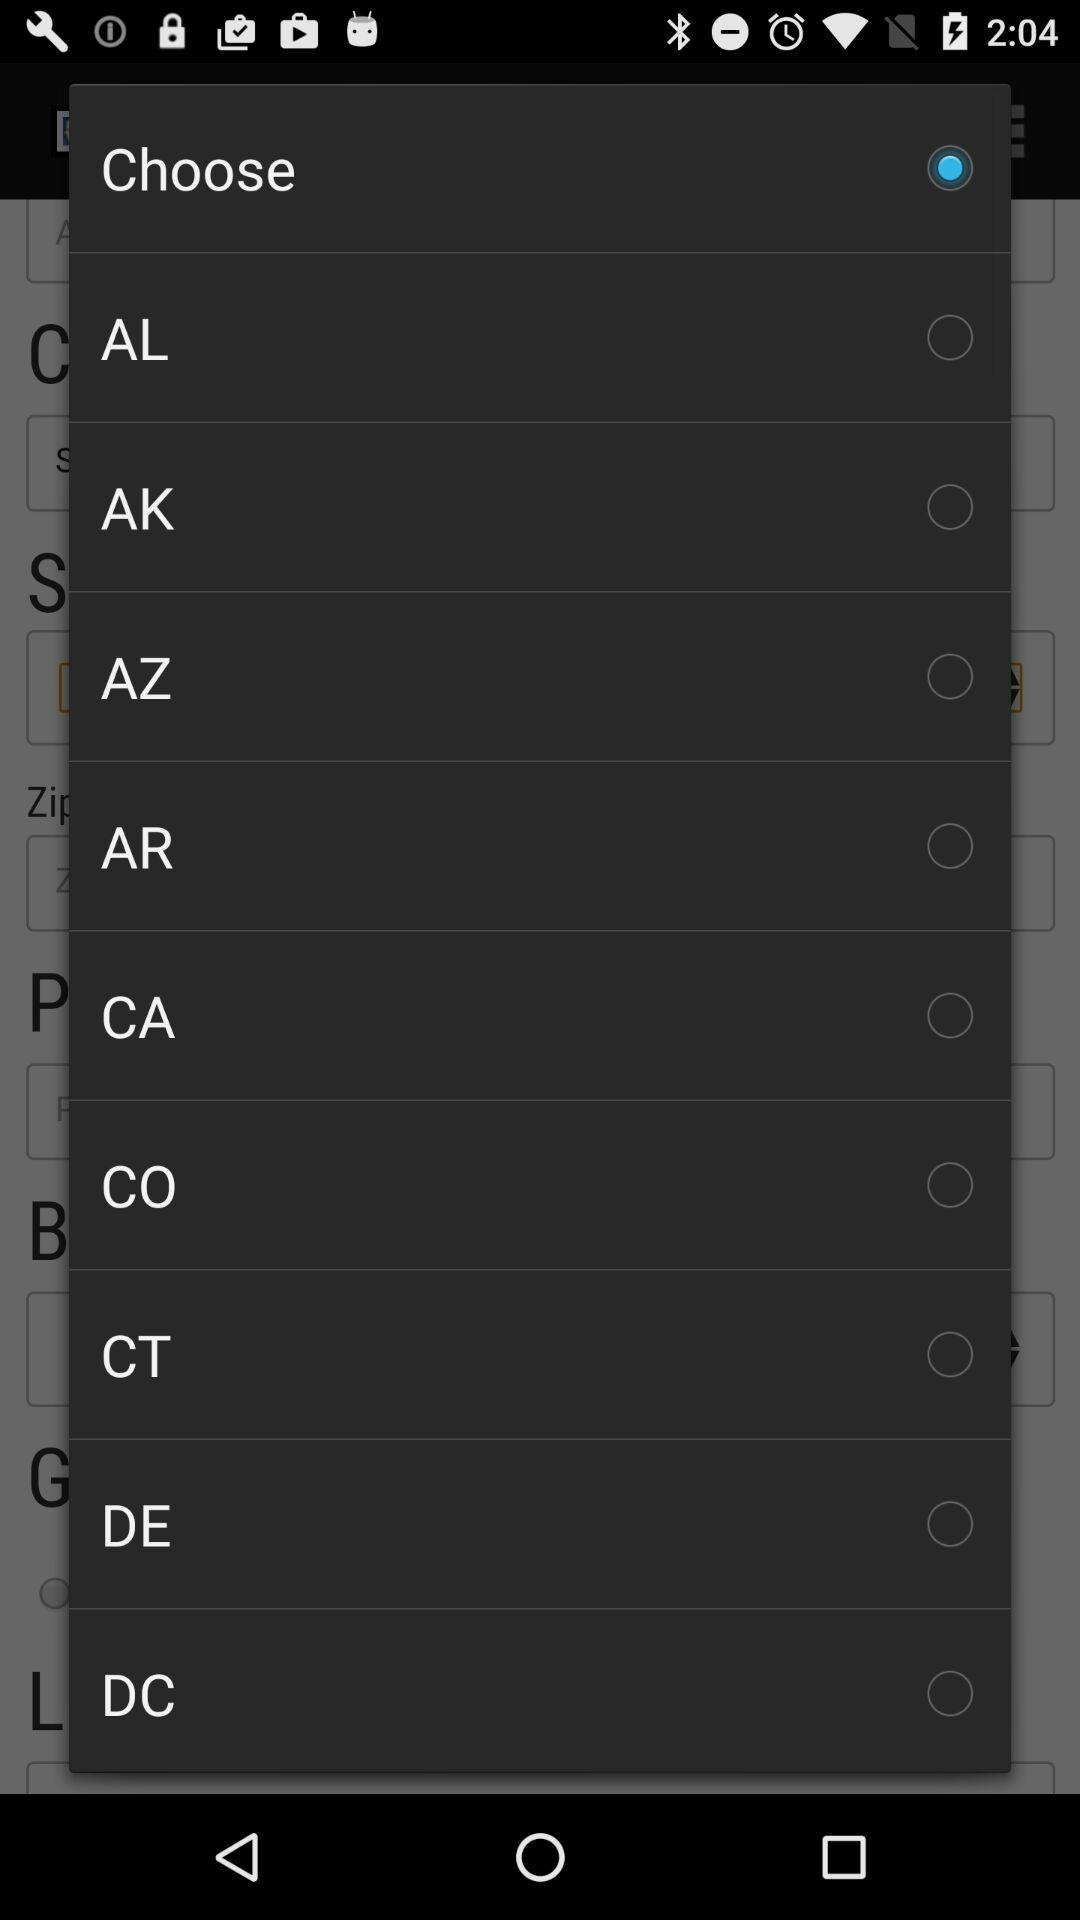What option is selected? The selected option is "Choose". 